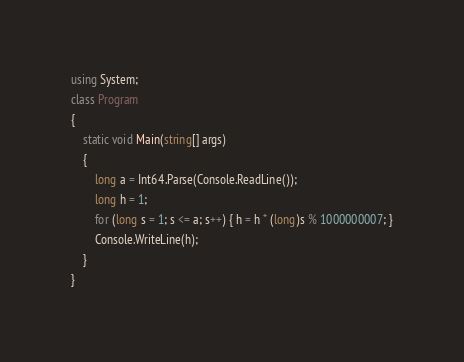<code> <loc_0><loc_0><loc_500><loc_500><_C#_>using System;
class Program
{
    static void Main(string[] args)
    {
        long a = Int64.Parse(Console.ReadLine());
        long h = 1;
        for (long s = 1; s <= a; s++) { h = h * (long)s % 1000000007; }
        Console.WriteLine(h);
    }
}</code> 